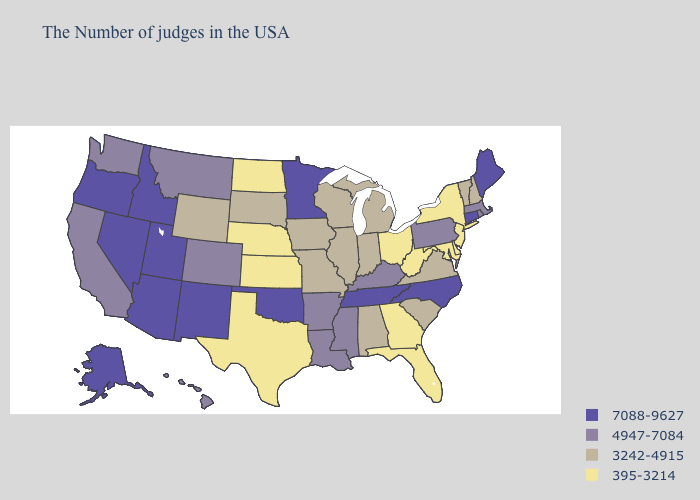What is the lowest value in the West?
Write a very short answer. 3242-4915. What is the highest value in the South ?
Answer briefly. 7088-9627. Does the first symbol in the legend represent the smallest category?
Concise answer only. No. What is the highest value in states that border Washington?
Give a very brief answer. 7088-9627. What is the value of North Carolina?
Quick response, please. 7088-9627. Which states have the highest value in the USA?
Answer briefly. Maine, Connecticut, North Carolina, Tennessee, Minnesota, Oklahoma, New Mexico, Utah, Arizona, Idaho, Nevada, Oregon, Alaska. Name the states that have a value in the range 4947-7084?
Give a very brief answer. Massachusetts, Rhode Island, Pennsylvania, Kentucky, Mississippi, Louisiana, Arkansas, Colorado, Montana, California, Washington, Hawaii. Is the legend a continuous bar?
Give a very brief answer. No. Name the states that have a value in the range 7088-9627?
Be succinct. Maine, Connecticut, North Carolina, Tennessee, Minnesota, Oklahoma, New Mexico, Utah, Arizona, Idaho, Nevada, Oregon, Alaska. Which states have the highest value in the USA?
Answer briefly. Maine, Connecticut, North Carolina, Tennessee, Minnesota, Oklahoma, New Mexico, Utah, Arizona, Idaho, Nevada, Oregon, Alaska. What is the highest value in states that border South Carolina?
Be succinct. 7088-9627. Which states have the lowest value in the MidWest?
Quick response, please. Ohio, Kansas, Nebraska, North Dakota. Name the states that have a value in the range 4947-7084?
Give a very brief answer. Massachusetts, Rhode Island, Pennsylvania, Kentucky, Mississippi, Louisiana, Arkansas, Colorado, Montana, California, Washington, Hawaii. Name the states that have a value in the range 7088-9627?
Answer briefly. Maine, Connecticut, North Carolina, Tennessee, Minnesota, Oklahoma, New Mexico, Utah, Arizona, Idaho, Nevada, Oregon, Alaska. What is the lowest value in states that border New Hampshire?
Concise answer only. 3242-4915. 